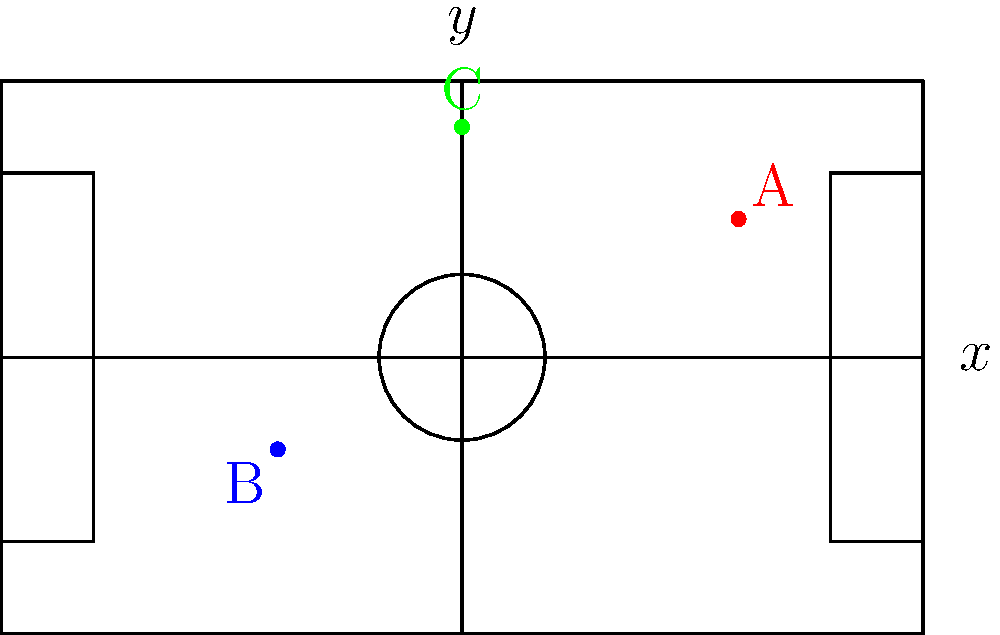In FIFA Soccer 2002, player positions are represented using a coordinate system where the center of the field is (0,0), the x-axis runs from left to right, and the y-axis runs from bottom to top. The field dimensions are 100 units wide and 60 units long.

Given the following player coordinates:
Player A: (30, 15)
Player B: (-20, -10)
Player C: (0, 25)

Which player is closest to the opponent's goal line (right side of the field)? To determine which player is closest to the opponent's goal line (right side of the field), we need to compare the x-coordinates of each player. The player with the largest x-coordinate will be closest to the right side of the field.

Let's examine each player's x-coordinate:

1. Player A: x = 30
2. Player B: x = -20
3. Player C: x = 0

Comparing these values:
30 > 0 > -20

Therefore, Player A has the largest x-coordinate (30), making them the closest to the opponent's goal line on the right side of the field.
Answer: Player A 